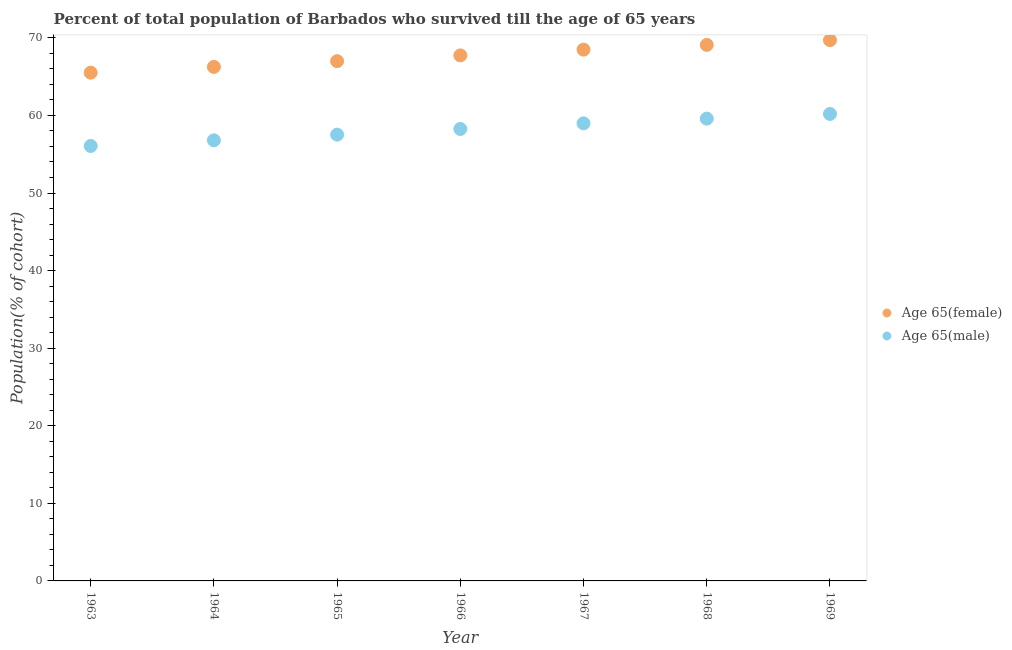What is the percentage of female population who survived till age of 65 in 1965?
Offer a terse response. 67. Across all years, what is the maximum percentage of female population who survived till age of 65?
Provide a succinct answer. 69.7. Across all years, what is the minimum percentage of female population who survived till age of 65?
Your response must be concise. 65.51. In which year was the percentage of female population who survived till age of 65 maximum?
Provide a succinct answer. 1969. What is the total percentage of female population who survived till age of 65 in the graph?
Give a very brief answer. 473.8. What is the difference between the percentage of male population who survived till age of 65 in 1963 and that in 1968?
Your answer should be compact. -3.52. What is the difference between the percentage of female population who survived till age of 65 in 1969 and the percentage of male population who survived till age of 65 in 1967?
Offer a very short reply. 10.72. What is the average percentage of male population who survived till age of 65 per year?
Provide a succinct answer. 58.2. In the year 1967, what is the difference between the percentage of male population who survived till age of 65 and percentage of female population who survived till age of 65?
Keep it short and to the point. -9.5. What is the ratio of the percentage of male population who survived till age of 65 in 1965 to that in 1967?
Keep it short and to the point. 0.98. Is the percentage of female population who survived till age of 65 in 1963 less than that in 1964?
Make the answer very short. Yes. What is the difference between the highest and the second highest percentage of female population who survived till age of 65?
Your answer should be very brief. 0.61. What is the difference between the highest and the lowest percentage of male population who survived till age of 65?
Offer a very short reply. 4.12. Is the sum of the percentage of female population who survived till age of 65 in 1967 and 1969 greater than the maximum percentage of male population who survived till age of 65 across all years?
Provide a succinct answer. Yes. Is the percentage of female population who survived till age of 65 strictly greater than the percentage of male population who survived till age of 65 over the years?
Provide a succinct answer. Yes. How many dotlines are there?
Provide a succinct answer. 2. What is the difference between two consecutive major ticks on the Y-axis?
Ensure brevity in your answer.  10. Does the graph contain any zero values?
Provide a short and direct response. No. What is the title of the graph?
Offer a very short reply. Percent of total population of Barbados who survived till the age of 65 years. Does "Official creditors" appear as one of the legend labels in the graph?
Give a very brief answer. No. What is the label or title of the X-axis?
Your answer should be very brief. Year. What is the label or title of the Y-axis?
Your answer should be compact. Population(% of cohort). What is the Population(% of cohort) in Age 65(female) in 1963?
Your answer should be compact. 65.51. What is the Population(% of cohort) of Age 65(male) in 1963?
Provide a short and direct response. 56.07. What is the Population(% of cohort) of Age 65(female) in 1964?
Your response must be concise. 66.26. What is the Population(% of cohort) in Age 65(male) in 1964?
Give a very brief answer. 56.8. What is the Population(% of cohort) in Age 65(female) in 1965?
Make the answer very short. 67. What is the Population(% of cohort) in Age 65(male) in 1965?
Keep it short and to the point. 57.53. What is the Population(% of cohort) of Age 65(female) in 1966?
Give a very brief answer. 67.74. What is the Population(% of cohort) in Age 65(male) in 1966?
Your response must be concise. 58.26. What is the Population(% of cohort) in Age 65(female) in 1967?
Provide a short and direct response. 68.48. What is the Population(% of cohort) in Age 65(male) in 1967?
Offer a very short reply. 58.99. What is the Population(% of cohort) of Age 65(female) in 1968?
Offer a very short reply. 69.09. What is the Population(% of cohort) of Age 65(male) in 1968?
Your answer should be very brief. 59.59. What is the Population(% of cohort) in Age 65(female) in 1969?
Provide a short and direct response. 69.7. What is the Population(% of cohort) in Age 65(male) in 1969?
Ensure brevity in your answer.  60.19. Across all years, what is the maximum Population(% of cohort) of Age 65(female)?
Ensure brevity in your answer.  69.7. Across all years, what is the maximum Population(% of cohort) of Age 65(male)?
Keep it short and to the point. 60.19. Across all years, what is the minimum Population(% of cohort) in Age 65(female)?
Provide a short and direct response. 65.51. Across all years, what is the minimum Population(% of cohort) in Age 65(male)?
Offer a terse response. 56.07. What is the total Population(% of cohort) of Age 65(female) in the graph?
Your answer should be very brief. 473.8. What is the total Population(% of cohort) of Age 65(male) in the graph?
Your answer should be very brief. 407.42. What is the difference between the Population(% of cohort) of Age 65(female) in 1963 and that in 1964?
Offer a terse response. -0.74. What is the difference between the Population(% of cohort) in Age 65(male) in 1963 and that in 1964?
Give a very brief answer. -0.73. What is the difference between the Population(% of cohort) of Age 65(female) in 1963 and that in 1965?
Your answer should be very brief. -1.49. What is the difference between the Population(% of cohort) of Age 65(male) in 1963 and that in 1965?
Your answer should be very brief. -1.46. What is the difference between the Population(% of cohort) of Age 65(female) in 1963 and that in 1966?
Your response must be concise. -2.23. What is the difference between the Population(% of cohort) in Age 65(male) in 1963 and that in 1966?
Your answer should be very brief. -2.19. What is the difference between the Population(% of cohort) of Age 65(female) in 1963 and that in 1967?
Offer a terse response. -2.97. What is the difference between the Population(% of cohort) of Age 65(male) in 1963 and that in 1967?
Offer a terse response. -2.92. What is the difference between the Population(% of cohort) in Age 65(female) in 1963 and that in 1968?
Provide a short and direct response. -3.58. What is the difference between the Population(% of cohort) of Age 65(male) in 1963 and that in 1968?
Keep it short and to the point. -3.52. What is the difference between the Population(% of cohort) of Age 65(female) in 1963 and that in 1969?
Offer a very short reply. -4.19. What is the difference between the Population(% of cohort) of Age 65(male) in 1963 and that in 1969?
Offer a terse response. -4.12. What is the difference between the Population(% of cohort) of Age 65(female) in 1964 and that in 1965?
Provide a succinct answer. -0.74. What is the difference between the Population(% of cohort) of Age 65(male) in 1964 and that in 1965?
Your answer should be compact. -0.73. What is the difference between the Population(% of cohort) in Age 65(female) in 1964 and that in 1966?
Ensure brevity in your answer.  -1.49. What is the difference between the Population(% of cohort) of Age 65(male) in 1964 and that in 1966?
Give a very brief answer. -1.46. What is the difference between the Population(% of cohort) of Age 65(female) in 1964 and that in 1967?
Ensure brevity in your answer.  -2.23. What is the difference between the Population(% of cohort) of Age 65(male) in 1964 and that in 1967?
Your answer should be very brief. -2.19. What is the difference between the Population(% of cohort) of Age 65(female) in 1964 and that in 1968?
Provide a succinct answer. -2.84. What is the difference between the Population(% of cohort) in Age 65(male) in 1964 and that in 1968?
Give a very brief answer. -2.79. What is the difference between the Population(% of cohort) in Age 65(female) in 1964 and that in 1969?
Your response must be concise. -3.45. What is the difference between the Population(% of cohort) in Age 65(male) in 1964 and that in 1969?
Keep it short and to the point. -3.39. What is the difference between the Population(% of cohort) in Age 65(female) in 1965 and that in 1966?
Your answer should be very brief. -0.74. What is the difference between the Population(% of cohort) of Age 65(male) in 1965 and that in 1966?
Make the answer very short. -0.73. What is the difference between the Population(% of cohort) of Age 65(female) in 1965 and that in 1967?
Offer a very short reply. -1.49. What is the difference between the Population(% of cohort) in Age 65(male) in 1965 and that in 1967?
Your response must be concise. -1.46. What is the difference between the Population(% of cohort) in Age 65(female) in 1965 and that in 1968?
Provide a succinct answer. -2.1. What is the difference between the Population(% of cohort) in Age 65(male) in 1965 and that in 1968?
Your answer should be very brief. -2.06. What is the difference between the Population(% of cohort) of Age 65(female) in 1965 and that in 1969?
Your response must be concise. -2.71. What is the difference between the Population(% of cohort) in Age 65(male) in 1965 and that in 1969?
Make the answer very short. -2.66. What is the difference between the Population(% of cohort) of Age 65(female) in 1966 and that in 1967?
Make the answer very short. -0.74. What is the difference between the Population(% of cohort) of Age 65(male) in 1966 and that in 1967?
Your answer should be very brief. -0.73. What is the difference between the Population(% of cohort) of Age 65(female) in 1966 and that in 1968?
Keep it short and to the point. -1.35. What is the difference between the Population(% of cohort) in Age 65(male) in 1966 and that in 1968?
Your answer should be compact. -1.33. What is the difference between the Population(% of cohort) of Age 65(female) in 1966 and that in 1969?
Make the answer very short. -1.96. What is the difference between the Population(% of cohort) in Age 65(male) in 1966 and that in 1969?
Ensure brevity in your answer.  -1.93. What is the difference between the Population(% of cohort) of Age 65(female) in 1967 and that in 1968?
Ensure brevity in your answer.  -0.61. What is the difference between the Population(% of cohort) in Age 65(male) in 1967 and that in 1968?
Your response must be concise. -0.6. What is the difference between the Population(% of cohort) of Age 65(female) in 1967 and that in 1969?
Keep it short and to the point. -1.22. What is the difference between the Population(% of cohort) in Age 65(male) in 1967 and that in 1969?
Offer a very short reply. -1.2. What is the difference between the Population(% of cohort) in Age 65(female) in 1968 and that in 1969?
Ensure brevity in your answer.  -0.61. What is the difference between the Population(% of cohort) of Age 65(male) in 1968 and that in 1969?
Ensure brevity in your answer.  -0.6. What is the difference between the Population(% of cohort) of Age 65(female) in 1963 and the Population(% of cohort) of Age 65(male) in 1964?
Your answer should be very brief. 8.72. What is the difference between the Population(% of cohort) of Age 65(female) in 1963 and the Population(% of cohort) of Age 65(male) in 1965?
Your answer should be very brief. 7.99. What is the difference between the Population(% of cohort) in Age 65(female) in 1963 and the Population(% of cohort) in Age 65(male) in 1966?
Give a very brief answer. 7.26. What is the difference between the Population(% of cohort) of Age 65(female) in 1963 and the Population(% of cohort) of Age 65(male) in 1967?
Your answer should be very brief. 6.53. What is the difference between the Population(% of cohort) in Age 65(female) in 1963 and the Population(% of cohort) in Age 65(male) in 1968?
Offer a terse response. 5.92. What is the difference between the Population(% of cohort) in Age 65(female) in 1963 and the Population(% of cohort) in Age 65(male) in 1969?
Your response must be concise. 5.32. What is the difference between the Population(% of cohort) of Age 65(female) in 1964 and the Population(% of cohort) of Age 65(male) in 1965?
Offer a terse response. 8.73. What is the difference between the Population(% of cohort) of Age 65(female) in 1964 and the Population(% of cohort) of Age 65(male) in 1966?
Your answer should be very brief. 8. What is the difference between the Population(% of cohort) in Age 65(female) in 1964 and the Population(% of cohort) in Age 65(male) in 1967?
Provide a succinct answer. 7.27. What is the difference between the Population(% of cohort) in Age 65(female) in 1964 and the Population(% of cohort) in Age 65(male) in 1968?
Give a very brief answer. 6.67. What is the difference between the Population(% of cohort) of Age 65(female) in 1964 and the Population(% of cohort) of Age 65(male) in 1969?
Give a very brief answer. 6.06. What is the difference between the Population(% of cohort) in Age 65(female) in 1965 and the Population(% of cohort) in Age 65(male) in 1966?
Keep it short and to the point. 8.74. What is the difference between the Population(% of cohort) in Age 65(female) in 1965 and the Population(% of cohort) in Age 65(male) in 1967?
Offer a very short reply. 8.01. What is the difference between the Population(% of cohort) of Age 65(female) in 1965 and the Population(% of cohort) of Age 65(male) in 1968?
Provide a short and direct response. 7.41. What is the difference between the Population(% of cohort) in Age 65(female) in 1965 and the Population(% of cohort) in Age 65(male) in 1969?
Ensure brevity in your answer.  6.81. What is the difference between the Population(% of cohort) in Age 65(female) in 1966 and the Population(% of cohort) in Age 65(male) in 1967?
Your answer should be compact. 8.75. What is the difference between the Population(% of cohort) in Age 65(female) in 1966 and the Population(% of cohort) in Age 65(male) in 1968?
Provide a short and direct response. 8.15. What is the difference between the Population(% of cohort) in Age 65(female) in 1966 and the Population(% of cohort) in Age 65(male) in 1969?
Keep it short and to the point. 7.55. What is the difference between the Population(% of cohort) in Age 65(female) in 1967 and the Population(% of cohort) in Age 65(male) in 1968?
Provide a short and direct response. 8.9. What is the difference between the Population(% of cohort) in Age 65(female) in 1967 and the Population(% of cohort) in Age 65(male) in 1969?
Your response must be concise. 8.29. What is the difference between the Population(% of cohort) in Age 65(female) in 1968 and the Population(% of cohort) in Age 65(male) in 1969?
Your response must be concise. 8.9. What is the average Population(% of cohort) in Age 65(female) per year?
Provide a succinct answer. 67.69. What is the average Population(% of cohort) in Age 65(male) per year?
Ensure brevity in your answer.  58.2. In the year 1963, what is the difference between the Population(% of cohort) in Age 65(female) and Population(% of cohort) in Age 65(male)?
Your response must be concise. 9.45. In the year 1964, what is the difference between the Population(% of cohort) of Age 65(female) and Population(% of cohort) of Age 65(male)?
Provide a succinct answer. 9.46. In the year 1965, what is the difference between the Population(% of cohort) in Age 65(female) and Population(% of cohort) in Age 65(male)?
Provide a short and direct response. 9.47. In the year 1966, what is the difference between the Population(% of cohort) of Age 65(female) and Population(% of cohort) of Age 65(male)?
Provide a short and direct response. 9.48. In the year 1967, what is the difference between the Population(% of cohort) of Age 65(female) and Population(% of cohort) of Age 65(male)?
Your answer should be compact. 9.5. In the year 1968, what is the difference between the Population(% of cohort) of Age 65(female) and Population(% of cohort) of Age 65(male)?
Offer a very short reply. 9.51. In the year 1969, what is the difference between the Population(% of cohort) of Age 65(female) and Population(% of cohort) of Age 65(male)?
Provide a short and direct response. 9.51. What is the ratio of the Population(% of cohort) in Age 65(female) in 1963 to that in 1964?
Your response must be concise. 0.99. What is the ratio of the Population(% of cohort) of Age 65(male) in 1963 to that in 1964?
Provide a short and direct response. 0.99. What is the ratio of the Population(% of cohort) in Age 65(female) in 1963 to that in 1965?
Keep it short and to the point. 0.98. What is the ratio of the Population(% of cohort) of Age 65(male) in 1963 to that in 1965?
Your answer should be very brief. 0.97. What is the ratio of the Population(% of cohort) in Age 65(female) in 1963 to that in 1966?
Ensure brevity in your answer.  0.97. What is the ratio of the Population(% of cohort) in Age 65(male) in 1963 to that in 1966?
Keep it short and to the point. 0.96. What is the ratio of the Population(% of cohort) of Age 65(female) in 1963 to that in 1967?
Offer a terse response. 0.96. What is the ratio of the Population(% of cohort) of Age 65(male) in 1963 to that in 1967?
Give a very brief answer. 0.95. What is the ratio of the Population(% of cohort) in Age 65(female) in 1963 to that in 1968?
Make the answer very short. 0.95. What is the ratio of the Population(% of cohort) in Age 65(male) in 1963 to that in 1968?
Make the answer very short. 0.94. What is the ratio of the Population(% of cohort) in Age 65(female) in 1963 to that in 1969?
Keep it short and to the point. 0.94. What is the ratio of the Population(% of cohort) in Age 65(male) in 1963 to that in 1969?
Give a very brief answer. 0.93. What is the ratio of the Population(% of cohort) in Age 65(female) in 1964 to that in 1965?
Offer a terse response. 0.99. What is the ratio of the Population(% of cohort) of Age 65(male) in 1964 to that in 1965?
Your response must be concise. 0.99. What is the ratio of the Population(% of cohort) of Age 65(female) in 1964 to that in 1966?
Your response must be concise. 0.98. What is the ratio of the Population(% of cohort) in Age 65(male) in 1964 to that in 1966?
Provide a succinct answer. 0.97. What is the ratio of the Population(% of cohort) of Age 65(female) in 1964 to that in 1967?
Offer a very short reply. 0.97. What is the ratio of the Population(% of cohort) of Age 65(male) in 1964 to that in 1967?
Offer a terse response. 0.96. What is the ratio of the Population(% of cohort) in Age 65(female) in 1964 to that in 1968?
Make the answer very short. 0.96. What is the ratio of the Population(% of cohort) of Age 65(male) in 1964 to that in 1968?
Your answer should be very brief. 0.95. What is the ratio of the Population(% of cohort) in Age 65(female) in 1964 to that in 1969?
Make the answer very short. 0.95. What is the ratio of the Population(% of cohort) of Age 65(male) in 1964 to that in 1969?
Your answer should be very brief. 0.94. What is the ratio of the Population(% of cohort) in Age 65(female) in 1965 to that in 1966?
Your answer should be compact. 0.99. What is the ratio of the Population(% of cohort) in Age 65(male) in 1965 to that in 1966?
Your answer should be very brief. 0.99. What is the ratio of the Population(% of cohort) in Age 65(female) in 1965 to that in 1967?
Keep it short and to the point. 0.98. What is the ratio of the Population(% of cohort) of Age 65(male) in 1965 to that in 1967?
Provide a short and direct response. 0.98. What is the ratio of the Population(% of cohort) of Age 65(female) in 1965 to that in 1968?
Ensure brevity in your answer.  0.97. What is the ratio of the Population(% of cohort) in Age 65(male) in 1965 to that in 1968?
Offer a very short reply. 0.97. What is the ratio of the Population(% of cohort) of Age 65(female) in 1965 to that in 1969?
Give a very brief answer. 0.96. What is the ratio of the Population(% of cohort) in Age 65(male) in 1965 to that in 1969?
Offer a very short reply. 0.96. What is the ratio of the Population(% of cohort) in Age 65(male) in 1966 to that in 1967?
Provide a succinct answer. 0.99. What is the ratio of the Population(% of cohort) in Age 65(female) in 1966 to that in 1968?
Ensure brevity in your answer.  0.98. What is the ratio of the Population(% of cohort) of Age 65(male) in 1966 to that in 1968?
Your answer should be compact. 0.98. What is the ratio of the Population(% of cohort) in Age 65(female) in 1966 to that in 1969?
Keep it short and to the point. 0.97. What is the ratio of the Population(% of cohort) in Age 65(male) in 1966 to that in 1969?
Make the answer very short. 0.97. What is the ratio of the Population(% of cohort) in Age 65(male) in 1967 to that in 1968?
Offer a very short reply. 0.99. What is the ratio of the Population(% of cohort) of Age 65(female) in 1967 to that in 1969?
Provide a short and direct response. 0.98. What is the ratio of the Population(% of cohort) in Age 65(male) in 1967 to that in 1969?
Your response must be concise. 0.98. What is the ratio of the Population(% of cohort) in Age 65(female) in 1968 to that in 1969?
Your answer should be very brief. 0.99. What is the difference between the highest and the second highest Population(% of cohort) of Age 65(female)?
Ensure brevity in your answer.  0.61. What is the difference between the highest and the second highest Population(% of cohort) in Age 65(male)?
Provide a succinct answer. 0.6. What is the difference between the highest and the lowest Population(% of cohort) in Age 65(female)?
Provide a short and direct response. 4.19. What is the difference between the highest and the lowest Population(% of cohort) in Age 65(male)?
Provide a short and direct response. 4.12. 